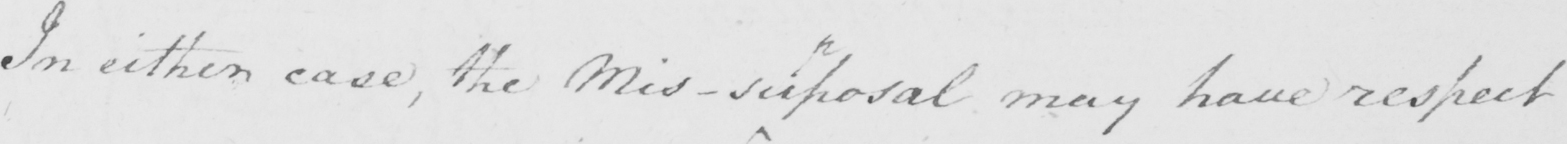What does this handwritten line say? In either case , the Mis-sup osal may have respect 